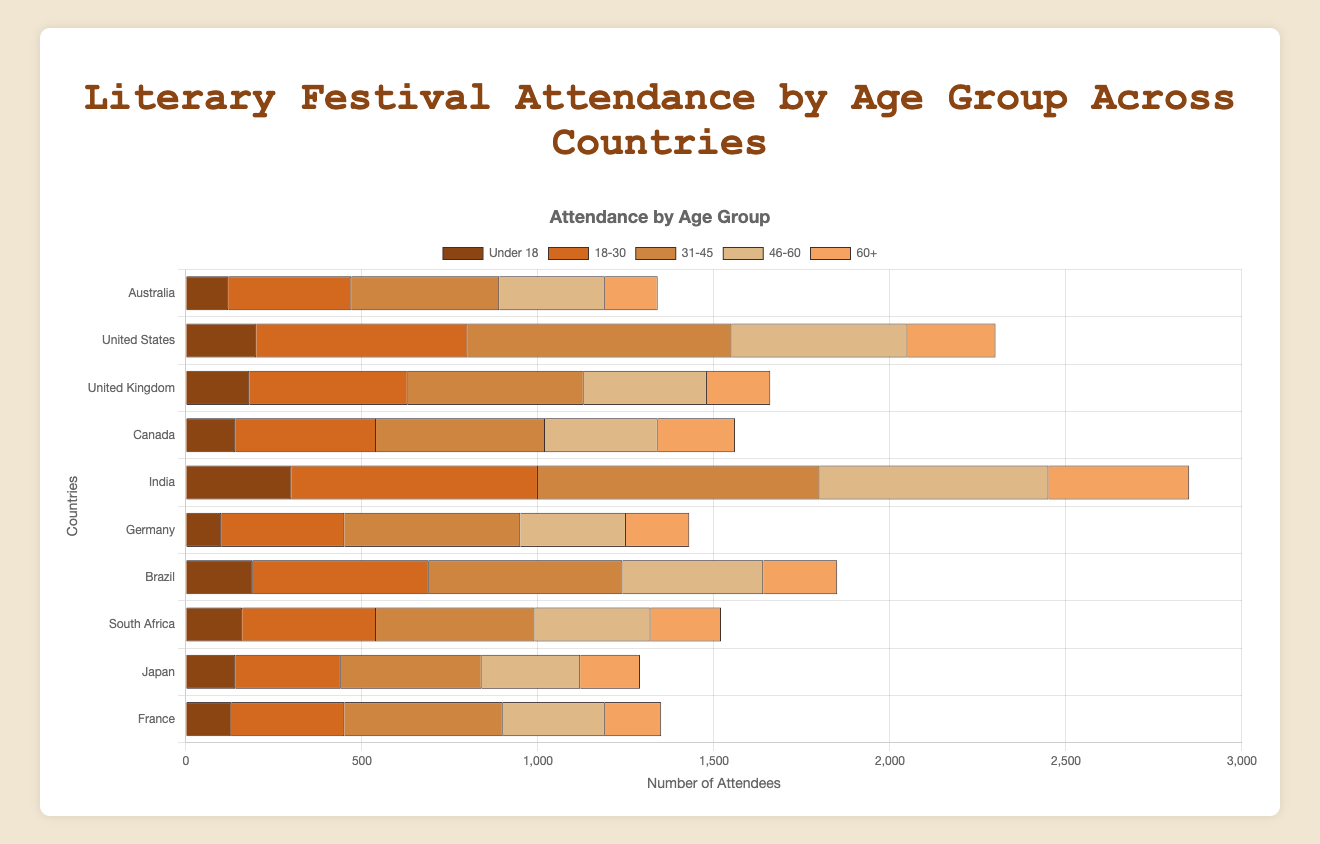What's the highest attendance recorded for the '31-45' age group and in which country? To find the highest attendance for the '31-45' age group, we examine the bar length for each country within this age group. India's bar is the longest at 800, which means it has the highest attendance for this age group.
Answer: 800, India Which country has the least attendance in the 'Under 18' age group? Checking the 'Under 18' group bars across all countries, we see that Germany has the shortest bar at 100, indicating the least attendance.
Answer: Germany How does the '60+' attendance in South Africa compare to Japan? For visual comparison, we measure the '60+' bars for both countries. South Africa has 200 attendees, whereas Japan has 170. South Africa's attendance is higher by 30.
Answer: South Africa has 30 more attendees What is the total number of attendees across all age groups in Australia? Summing up the attendees for all age groups in Australia: 120 (Under 18) + 350 (18-30) + 420 (31-45) + 300 (46-60) + 150 (60+) = 1340.
Answer: 1340 Which age group has the highest combined attendance across all countries? To find this, sum the number of attendees for each age group across all countries:
Under 18: 120 + 200 + 180 + 140 + 300 + 100 + 190 + 160 + 140 + 130 = 1660
18-30: 350 + 600 + 450 + 400 + 700 + 350 + 500 + 380 + 300 + 320 = 4350
31-45: 420 + 750 + 500 + 480 + 800 + 500 + 550 + 450 + 400 + 450 = 5300
46-60: 300 + 500 + 350 + 320 + 650 + 300 + 400 + 330 + 280 + 290 = 3720
60+: 150 + 250 + 180 + 220 + 400 + 180 + 210 + 200 + 170 + 160 = 2120
The '31-45' age group has the highest combined attendance at 5300.
Answer: 31-45 Is the attendance of 'Under 18' in Brazil notably different from that in Canada? Comparing their 'Under 18' bars, Brazil has 190 attendees and Canada has 140. The difference is 50, with Brazil having more attendees in this age group.
Answer: Brazil has 50 more attendees What is the average attendance for the '18-30' age group across all countries? Sum the '18-30' attendees across all countries and divide by the number of countries: (350 + 600 + 450 + 400 + 700 + 350 + 500 + 380 + 300 + 320) / 10 = 4350 / 10 = 435.
Answer: 435 